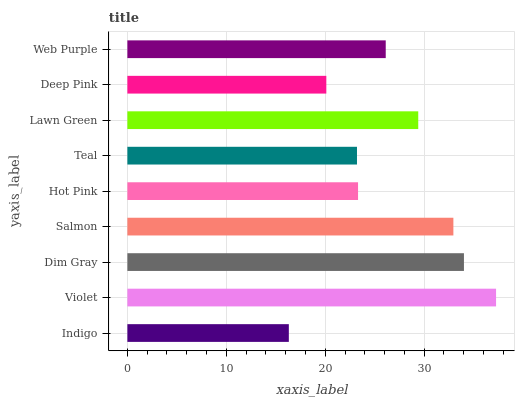Is Indigo the minimum?
Answer yes or no. Yes. Is Violet the maximum?
Answer yes or no. Yes. Is Dim Gray the minimum?
Answer yes or no. No. Is Dim Gray the maximum?
Answer yes or no. No. Is Violet greater than Dim Gray?
Answer yes or no. Yes. Is Dim Gray less than Violet?
Answer yes or no. Yes. Is Dim Gray greater than Violet?
Answer yes or no. No. Is Violet less than Dim Gray?
Answer yes or no. No. Is Web Purple the high median?
Answer yes or no. Yes. Is Web Purple the low median?
Answer yes or no. Yes. Is Dim Gray the high median?
Answer yes or no. No. Is Lawn Green the low median?
Answer yes or no. No. 